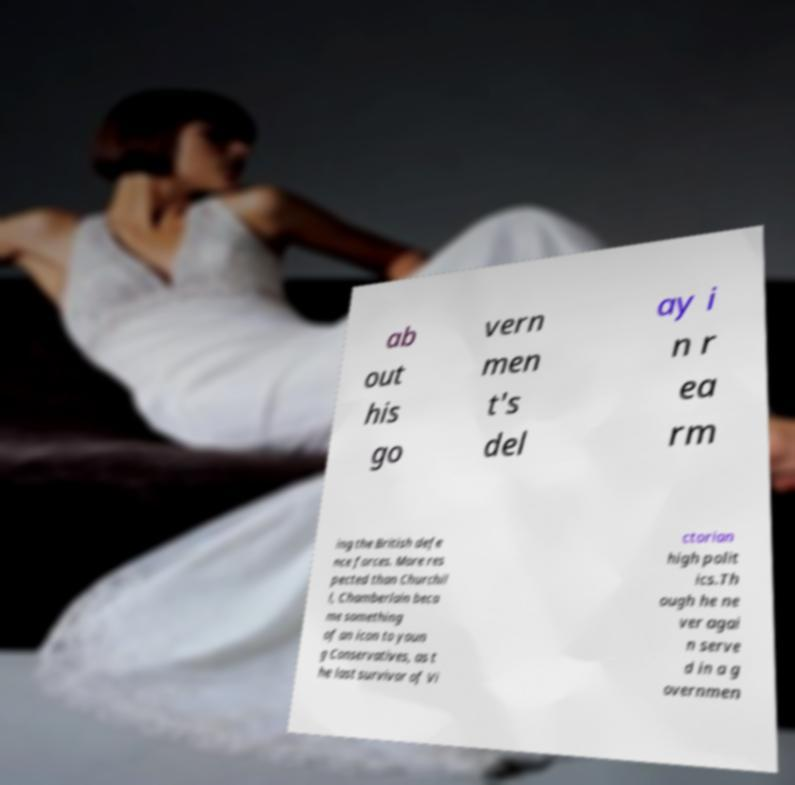Could you extract and type out the text from this image? ab out his go vern men t's del ay i n r ea rm ing the British defe nce forces. More res pected than Churchil l, Chamberlain beca me something of an icon to youn g Conservatives, as t he last survivor of Vi ctorian high polit ics.Th ough he ne ver agai n serve d in a g overnmen 